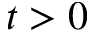Convert formula to latex. <formula><loc_0><loc_0><loc_500><loc_500>t > 0</formula> 